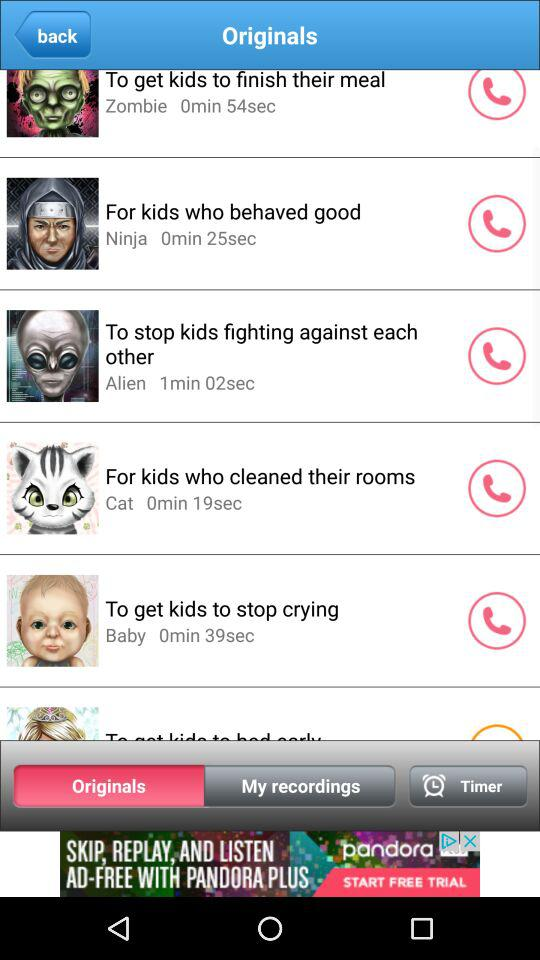Which ringtone has a duration of 25 seconds? The ringtone is "For kids who behaved good". 